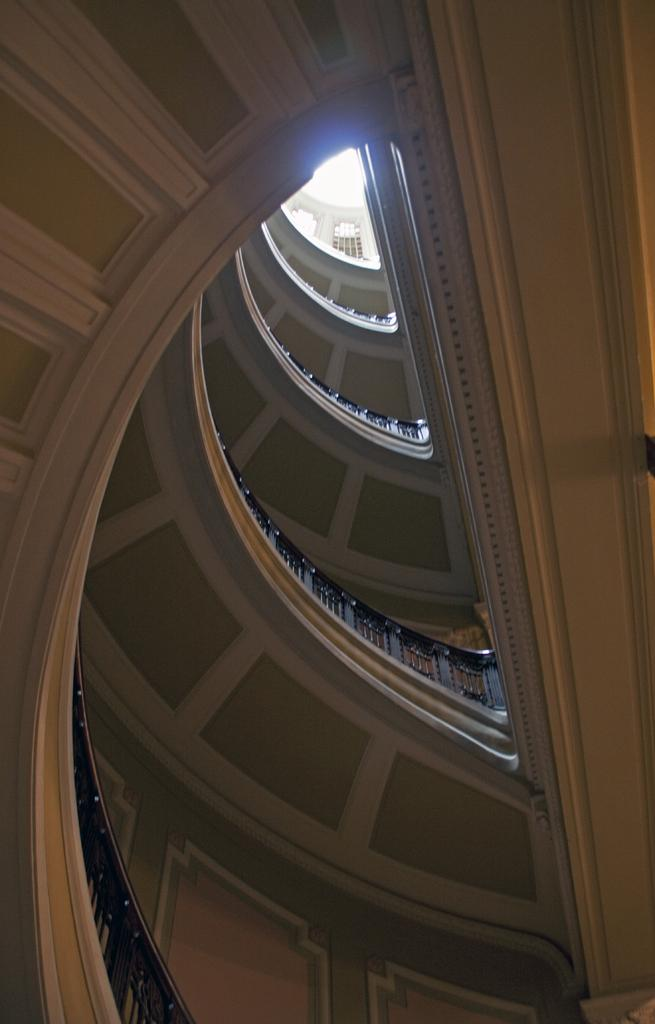What type of location is depicted in the image? The image shows an inside view of a building. What can be seen in the image that provides a contrasting color? There are black color railings in the image. What area in the image is predominantly white? There is a white area in the image. How does the ray of sunshine affect the toe of the person in the image? There is no person or ray of sunshine present in the image. What type of pleasure can be experienced by the person in the image? There is no person present in the image, so it is impossible to determine what type of pleasure they might experience. 